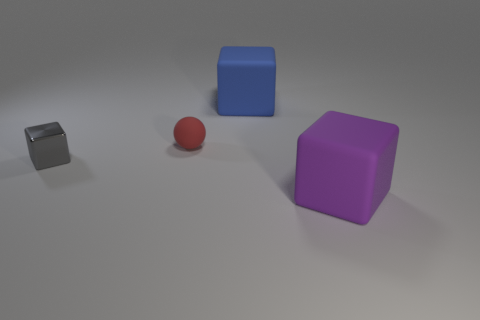What size is the red matte ball that is to the left of the big blue rubber object?
Provide a short and direct response. Small. What shape is the rubber object that is on the left side of the big blue object that is to the right of the gray shiny cube?
Your response must be concise. Sphere. The other matte object that is the same shape as the big blue thing is what color?
Your answer should be compact. Purple. There is a rubber cube that is behind the purple matte block; does it have the same size as the purple matte object?
Keep it short and to the point. Yes. What number of other big objects have the same material as the red thing?
Ensure brevity in your answer.  2. There is a blue thing right of the small thing that is in front of the sphere that is behind the large purple cube; what is its material?
Make the answer very short. Rubber. What color is the rubber block that is on the right side of the large matte object to the left of the large purple cube?
Offer a terse response. Purple. What is the color of the rubber sphere that is the same size as the metallic cube?
Keep it short and to the point. Red. What number of large objects are shiny things or red matte things?
Offer a very short reply. 0. Are there more things in front of the big blue matte thing than small metallic objects right of the metallic block?
Offer a terse response. Yes. 